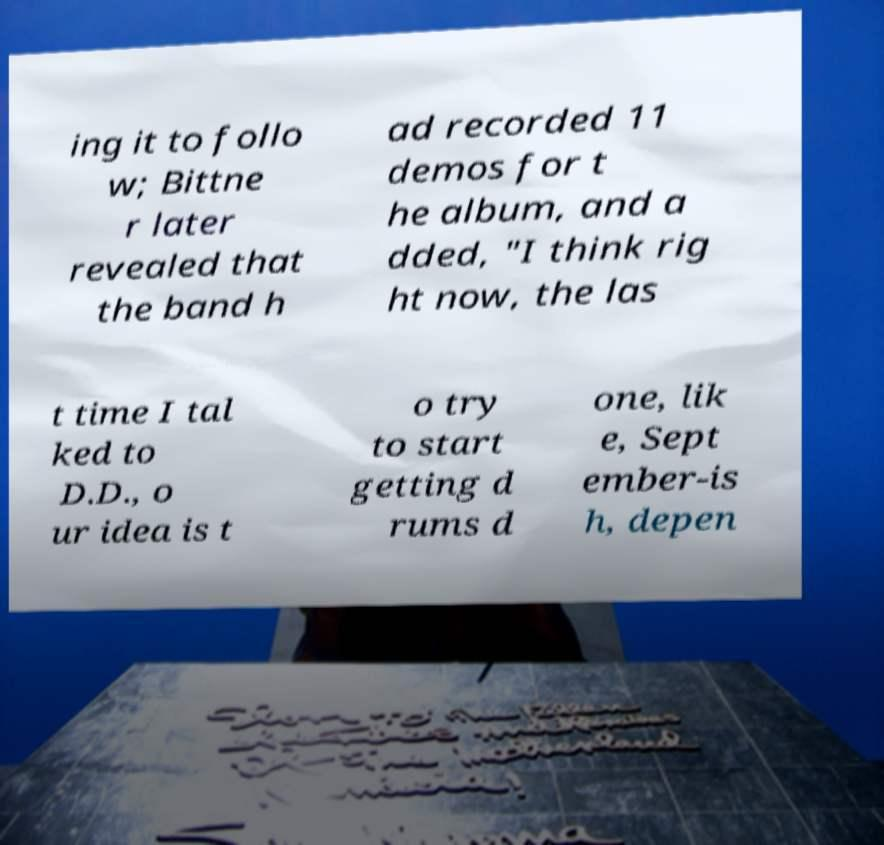Please read and relay the text visible in this image. What does it say? ing it to follo w; Bittne r later revealed that the band h ad recorded 11 demos for t he album, and a dded, "I think rig ht now, the las t time I tal ked to D.D., o ur idea is t o try to start getting d rums d one, lik e, Sept ember-is h, depen 